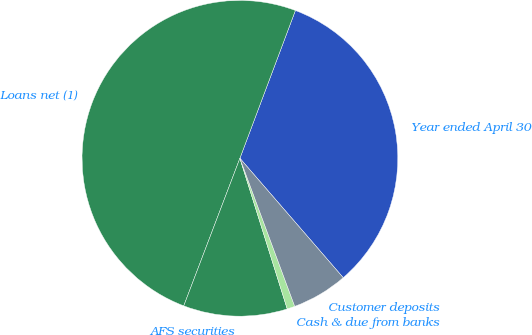<chart> <loc_0><loc_0><loc_500><loc_500><pie_chart><fcel>Year ended April 30<fcel>Loans net (1)<fcel>AFS securities<fcel>Cash & due from banks<fcel>Customer deposits<nl><fcel>32.93%<fcel>49.93%<fcel>10.63%<fcel>0.8%<fcel>5.71%<nl></chart> 